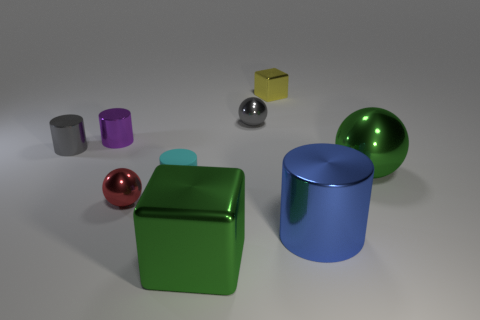Is there anything else that has the same material as the small cyan thing?
Offer a terse response. No. Is there any other thing that is the same size as the green sphere?
Offer a very short reply. Yes. There is a large green thing on the left side of the yellow block; what is its shape?
Offer a terse response. Cube. There is a big object that is the same color as the large shiny block; what is its material?
Make the answer very short. Metal. There is a metal cylinder in front of the tiny metal sphere in front of the purple cylinder; what is its color?
Make the answer very short. Blue. Is the blue metal thing the same size as the matte cylinder?
Your answer should be compact. No. There is another large object that is the same shape as the red object; what is its material?
Give a very brief answer. Metal. What number of metallic objects are the same size as the green cube?
Give a very brief answer. 2. What color is the other tiny cylinder that is made of the same material as the small gray cylinder?
Your answer should be very brief. Purple. Is the number of small shiny cylinders less than the number of small cyan cylinders?
Your answer should be very brief. No. 